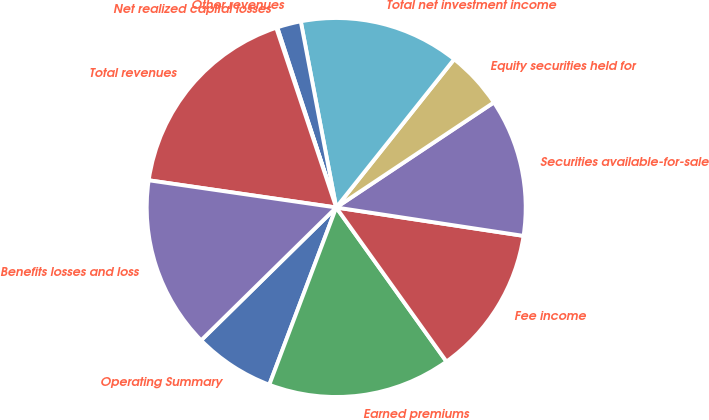<chart> <loc_0><loc_0><loc_500><loc_500><pie_chart><fcel>Operating Summary<fcel>Earned premiums<fcel>Fee income<fcel>Securities available-for-sale<fcel>Equity securities held for<fcel>Total net investment income<fcel>Other revenues<fcel>Net realized capital losses<fcel>Total revenues<fcel>Benefits losses and loss<nl><fcel>6.89%<fcel>15.63%<fcel>12.72%<fcel>11.75%<fcel>4.95%<fcel>13.69%<fcel>2.04%<fcel>0.09%<fcel>17.58%<fcel>14.66%<nl></chart> 